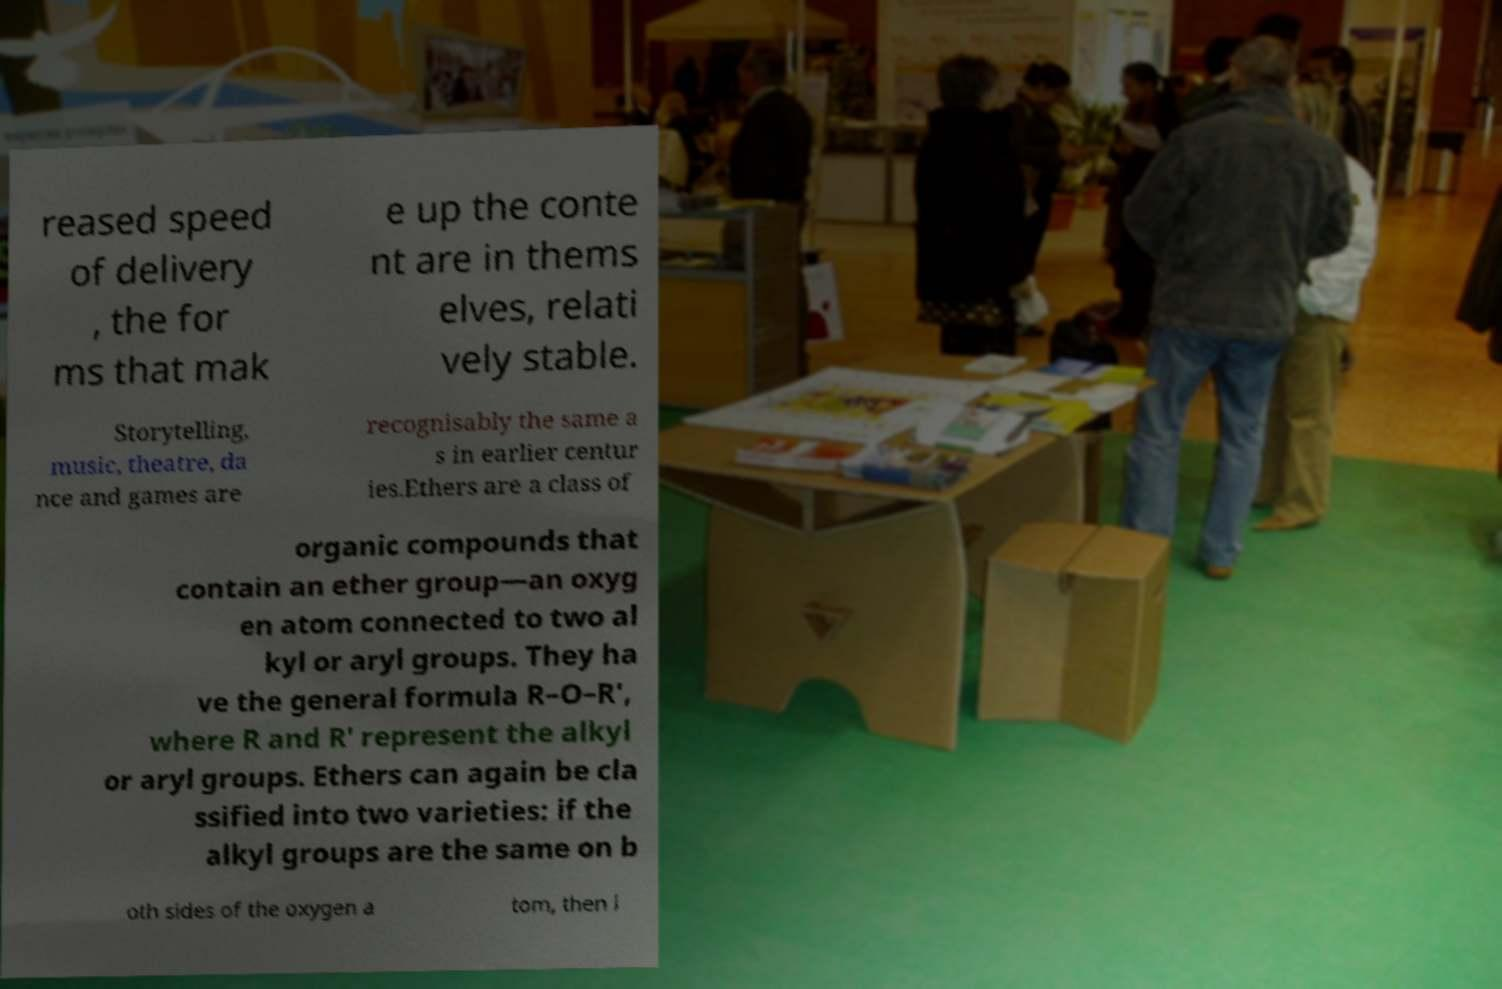Could you assist in decoding the text presented in this image and type it out clearly? reased speed of delivery , the for ms that mak e up the conte nt are in thems elves, relati vely stable. Storytelling, music, theatre, da nce and games are recognisably the same a s in earlier centur ies.Ethers are a class of organic compounds that contain an ether group—an oxyg en atom connected to two al kyl or aryl groups. They ha ve the general formula R–O–R′, where R and R′ represent the alkyl or aryl groups. Ethers can again be cla ssified into two varieties: if the alkyl groups are the same on b oth sides of the oxygen a tom, then i 